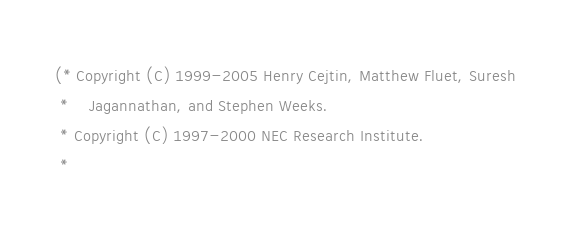<code> <loc_0><loc_0><loc_500><loc_500><_SML_>(* Copyright (C) 1999-2005 Henry Cejtin, Matthew Fluet, Suresh
 *    Jagannathan, and Stephen Weeks.
 * Copyright (C) 1997-2000 NEC Research Institute.
 *</code> 